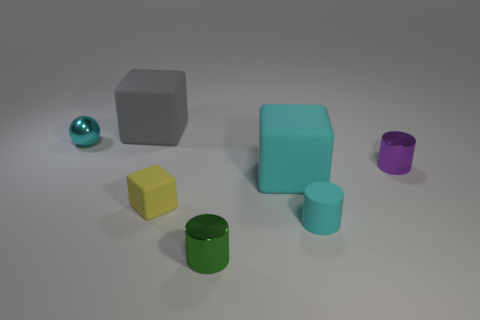Add 1 blue cubes. How many objects exist? 8 Subtract all blocks. How many objects are left? 4 Add 1 cyan metallic balls. How many cyan metallic balls are left? 2 Add 1 cylinders. How many cylinders exist? 4 Subtract 0 gray cylinders. How many objects are left? 7 Subtract all tiny cyan balls. Subtract all tiny green metallic objects. How many objects are left? 5 